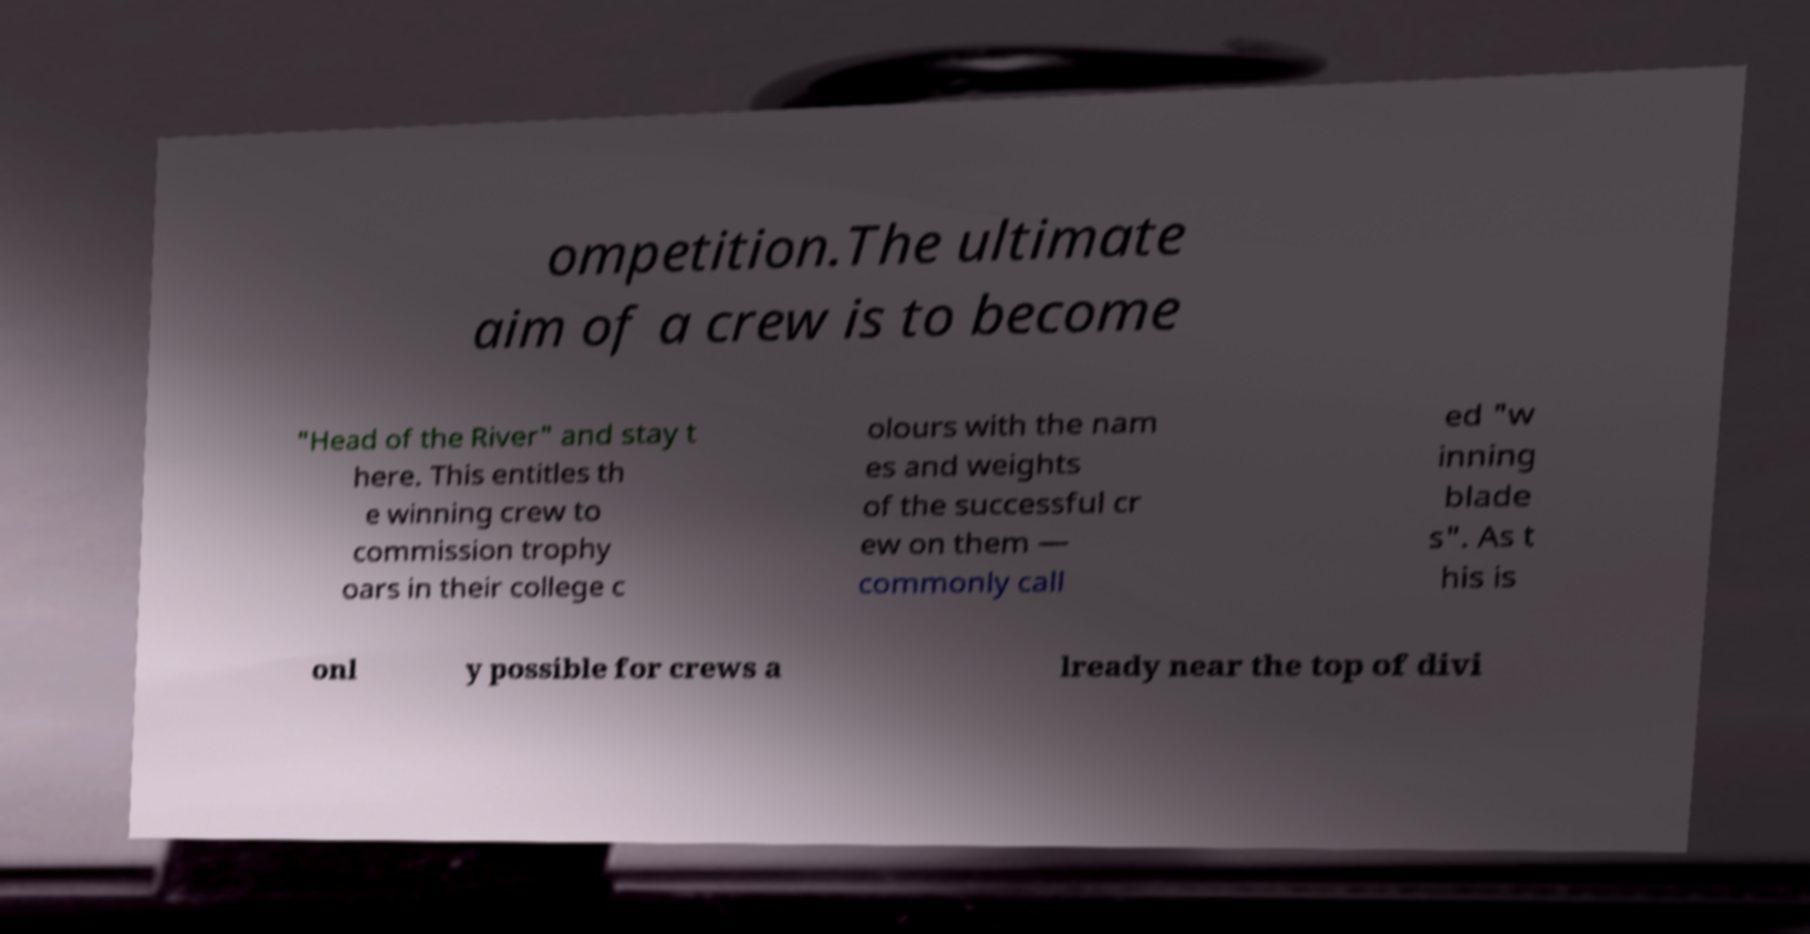What messages or text are displayed in this image? I need them in a readable, typed format. ompetition.The ultimate aim of a crew is to become "Head of the River" and stay t here. This entitles th e winning crew to commission trophy oars in their college c olours with the nam es and weights of the successful cr ew on them — commonly call ed "w inning blade s". As t his is onl y possible for crews a lready near the top of divi 